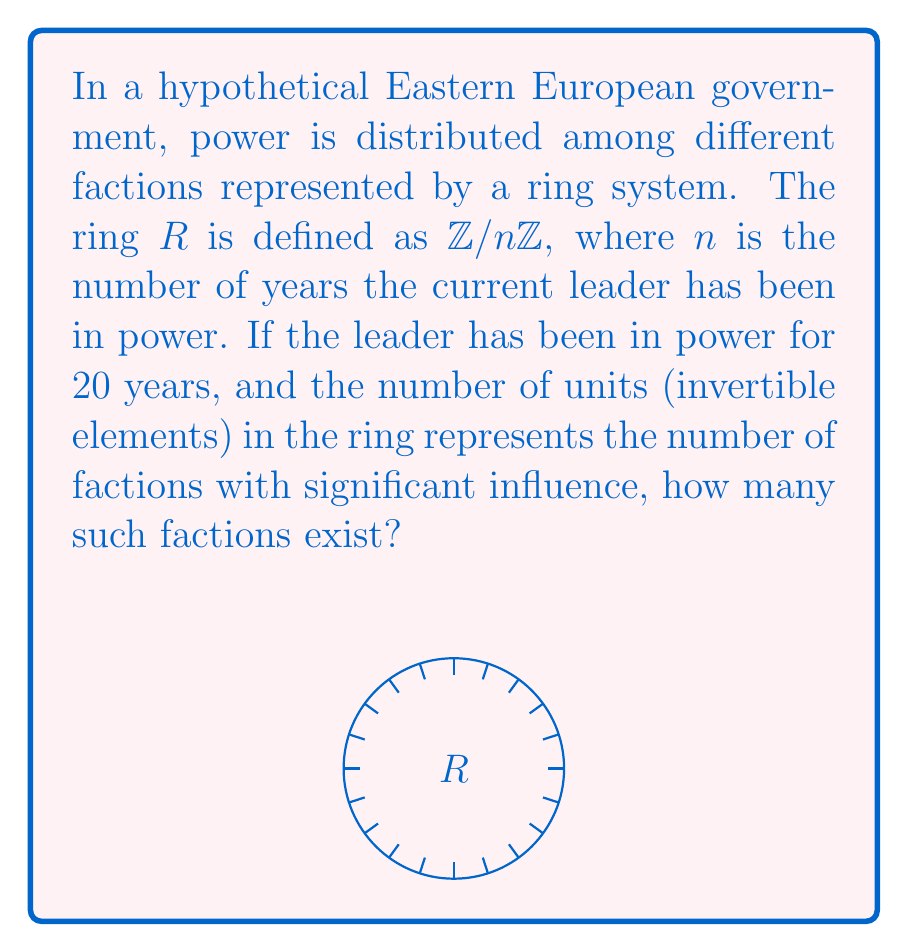Could you help me with this problem? To solve this problem, we need to follow these steps:

1) The ring is defined as $R = \mathbb{Z}/n\mathbb{Z}$, where $n = 20$.

2) In a ring $\mathbb{Z}/n\mathbb{Z}$, the number of units (invertible elements) is equal to the number of integers less than $n$ that are coprime to $n$. This is given by Euler's totient function $\phi(n)$.

3) To calculate $\phi(20)$, we first factorize 20:
   $20 = 2^2 \times 5$

4) The formula for Euler's totient function for a prime factorization $n = p_1^{a_1} \times p_2^{a_2} \times ... \times p_k^{a_k}$ is:
   $$\phi(n) = n \times \prod_{i=1}^k (1 - \frac{1}{p_i})$$

5) Applying this to our case:
   $$\phi(20) = 20 \times (1 - \frac{1}{2}) \times (1 - \frac{1}{5})$$

6) Calculating:
   $$\phi(20) = 20 \times \frac{1}{2} \times \frac{4}{5} = 8$$

Therefore, there are 8 units in the ring $\mathbb{Z}/20\mathbb{Z}$, representing 8 factions with significant influence in this hypothetical government system.
Answer: $8$ factions 